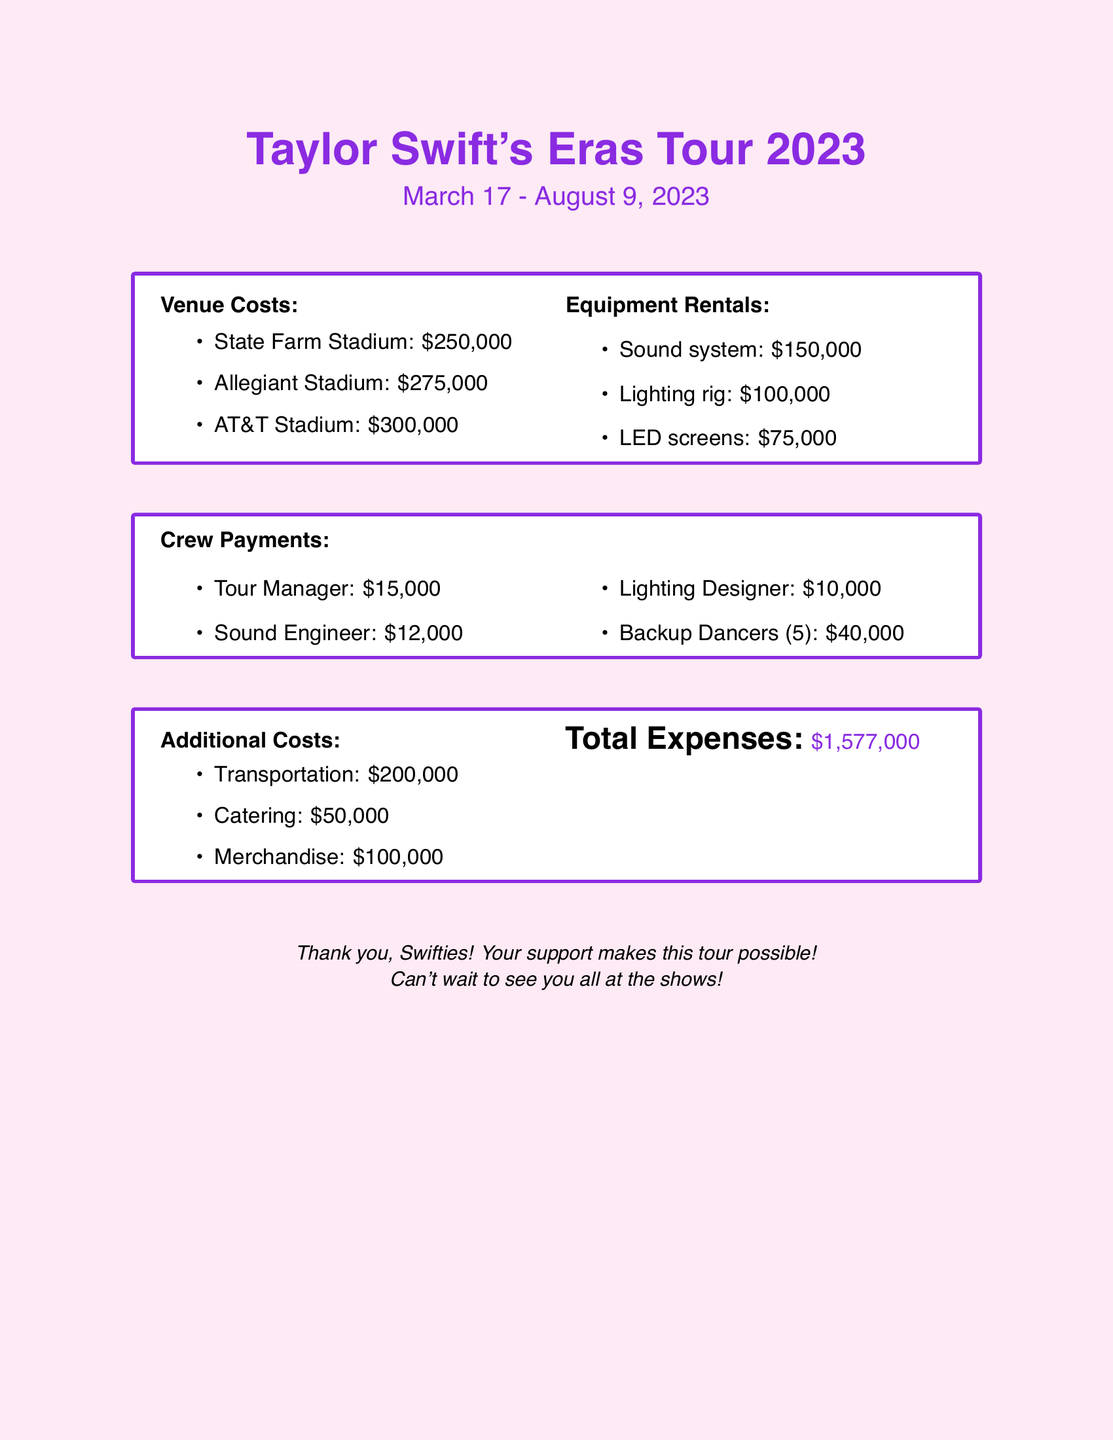what is the total amount for venue costs? The venue costs listed are $250,000 for State Farm Stadium, $275,000 for Allegiant Stadium, and $300,000 for AT&T Stadium. Adding these gives a total of $825,000.
Answer: $825,000 what is the cost for the sound system rental? The document specifies that the sound system rental cost is $150,000.
Answer: $150,000 how many backup dancers are listed? The document states that there are 5 backup dancers in the crew payments section.
Answer: 5 what is the total expense amount listed? The total expenses calculated from all sections are presented in the document as $1,577,000.
Answer: $1,577,000 which venue has the highest cost? The highest venue cost is for AT&T Stadium, which is $300,000.
Answer: AT&T Stadium how much is spent on catering? The document notes that the catering cost is $50,000.
Answer: $50,000 what is the combined cost of equipment rentals? The equipment rentals sum up the costs of the sound system, lighting rig, and LED screens to $325,000.
Answer: $325,000 what is the payment for the Tour Manager? The payment specified for the Tour Manager is $15,000.
Answer: $15,000 which color is used for the document's background? The background color used in the document is a shade of pink specified as swiftpink.
Answer: swiftpink 